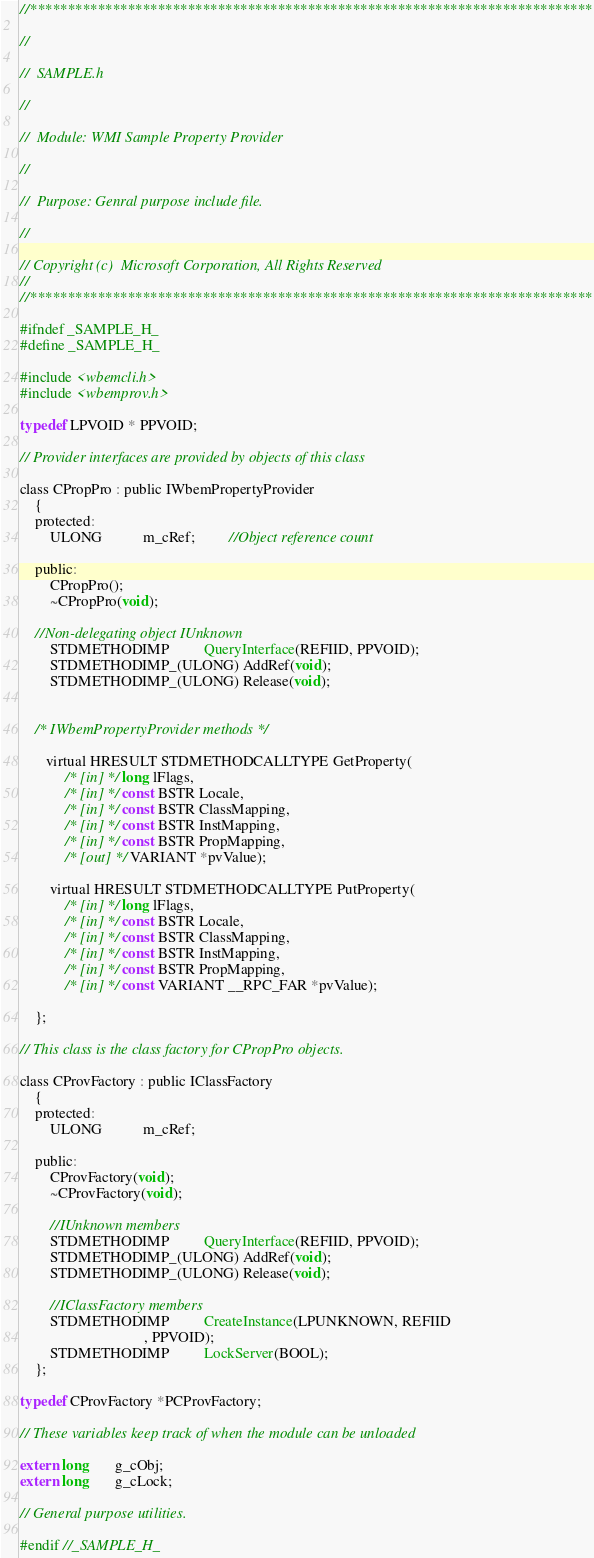<code> <loc_0><loc_0><loc_500><loc_500><_C_>//***************************************************************************

//

//  SAMPLE.h

//

//  Module: WMI Sample Property Provider

//

//  Purpose: Genral purpose include file.

//

// Copyright (c)  Microsoft Corporation, All Rights Reserved
//
//***************************************************************************

#ifndef _SAMPLE_H_
#define _SAMPLE_H_

#include <wbemcli.h>
#include <wbemprov.h>

typedef LPVOID * PPVOID;

// Provider interfaces are provided by objects of this class
 
class CPropPro : public IWbemPropertyProvider
    {
    protected:
        ULONG           m_cRef;         //Object reference count
   
    public:
        CPropPro();
        ~CPropPro(void);

    //Non-delegating object IUnknown
        STDMETHODIMP         QueryInterface(REFIID, PPVOID);
        STDMETHODIMP_(ULONG) AddRef(void);
        STDMETHODIMP_(ULONG) Release(void);

    
    /* IWbemPropertyProvider methods */

       virtual HRESULT STDMETHODCALLTYPE GetProperty( 
           	/* [in] */ long lFlags,
            /* [in] */ const BSTR Locale,						   
            /* [in] */ const BSTR ClassMapping,
            /* [in] */ const BSTR InstMapping,
            /* [in] */ const BSTR PropMapping,
            /* [out] */ VARIANT *pvValue);
        
        virtual HRESULT STDMETHODCALLTYPE PutProperty( 
            /* [in] */ long lFlags,
            /* [in] */ const BSTR Locale,						   
            /* [in] */ const BSTR ClassMapping,
            /* [in] */ const BSTR InstMapping,
            /* [in] */ const BSTR PropMapping,
            /* [in] */ const VARIANT __RPC_FAR *pvValue);

    };

// This class is the class factory for CPropPro objects.

class CProvFactory : public IClassFactory
    {
    protected:
        ULONG           m_cRef;

    public:
        CProvFactory(void);
        ~CProvFactory(void);

        //IUnknown members
        STDMETHODIMP         QueryInterface(REFIID, PPVOID);
        STDMETHODIMP_(ULONG) AddRef(void);
        STDMETHODIMP_(ULONG) Release(void);

        //IClassFactory members
        STDMETHODIMP         CreateInstance(LPUNKNOWN, REFIID
                                 , PPVOID);
        STDMETHODIMP         LockServer(BOOL);
    };

typedef CProvFactory *PCProvFactory;

// These variables keep track of when the module can be unloaded

extern long       g_cObj;
extern long       g_cLock;

// General purpose utilities.  

#endif //_SAMPLE_H_



</code> 